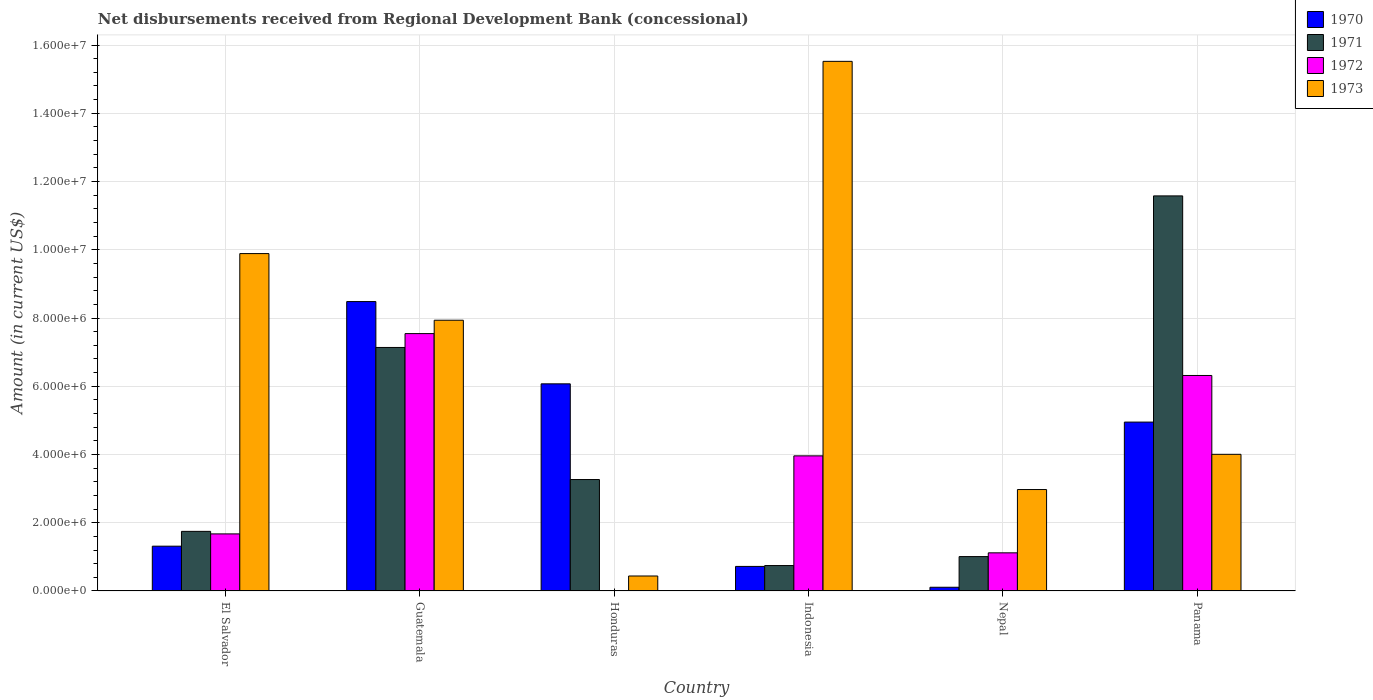How many different coloured bars are there?
Keep it short and to the point. 4. Are the number of bars on each tick of the X-axis equal?
Ensure brevity in your answer.  No. How many bars are there on the 3rd tick from the left?
Provide a short and direct response. 3. How many bars are there on the 1st tick from the right?
Offer a terse response. 4. What is the label of the 1st group of bars from the left?
Your answer should be very brief. El Salvador. What is the amount of disbursements received from Regional Development Bank in 1972 in Panama?
Provide a succinct answer. 6.32e+06. Across all countries, what is the maximum amount of disbursements received from Regional Development Bank in 1970?
Your response must be concise. 8.48e+06. Across all countries, what is the minimum amount of disbursements received from Regional Development Bank in 1970?
Provide a short and direct response. 1.09e+05. In which country was the amount of disbursements received from Regional Development Bank in 1972 maximum?
Provide a short and direct response. Guatemala. What is the total amount of disbursements received from Regional Development Bank in 1973 in the graph?
Provide a short and direct response. 4.08e+07. What is the difference between the amount of disbursements received from Regional Development Bank in 1970 in El Salvador and that in Nepal?
Ensure brevity in your answer.  1.20e+06. What is the difference between the amount of disbursements received from Regional Development Bank in 1973 in Nepal and the amount of disbursements received from Regional Development Bank in 1972 in Honduras?
Your response must be concise. 2.97e+06. What is the average amount of disbursements received from Regional Development Bank in 1972 per country?
Make the answer very short. 3.44e+06. What is the difference between the amount of disbursements received from Regional Development Bank of/in 1972 and amount of disbursements received from Regional Development Bank of/in 1973 in Panama?
Your response must be concise. 2.31e+06. What is the ratio of the amount of disbursements received from Regional Development Bank in 1970 in El Salvador to that in Nepal?
Ensure brevity in your answer.  12.05. What is the difference between the highest and the second highest amount of disbursements received from Regional Development Bank in 1971?
Ensure brevity in your answer.  4.44e+06. What is the difference between the highest and the lowest amount of disbursements received from Regional Development Bank in 1971?
Offer a terse response. 1.08e+07. In how many countries, is the amount of disbursements received from Regional Development Bank in 1971 greater than the average amount of disbursements received from Regional Development Bank in 1971 taken over all countries?
Provide a succinct answer. 2. Is the sum of the amount of disbursements received from Regional Development Bank in 1973 in Nepal and Panama greater than the maximum amount of disbursements received from Regional Development Bank in 1972 across all countries?
Ensure brevity in your answer.  No. Is it the case that in every country, the sum of the amount of disbursements received from Regional Development Bank in 1971 and amount of disbursements received from Regional Development Bank in 1970 is greater than the sum of amount of disbursements received from Regional Development Bank in 1972 and amount of disbursements received from Regional Development Bank in 1973?
Ensure brevity in your answer.  No. What is the difference between two consecutive major ticks on the Y-axis?
Your answer should be compact. 2.00e+06. Does the graph contain any zero values?
Your response must be concise. Yes. Does the graph contain grids?
Provide a short and direct response. Yes. How many legend labels are there?
Make the answer very short. 4. What is the title of the graph?
Provide a succinct answer. Net disbursements received from Regional Development Bank (concessional). Does "1988" appear as one of the legend labels in the graph?
Ensure brevity in your answer.  No. What is the label or title of the X-axis?
Keep it short and to the point. Country. What is the Amount (in current US$) of 1970 in El Salvador?
Offer a terse response. 1.31e+06. What is the Amount (in current US$) of 1971 in El Salvador?
Give a very brief answer. 1.75e+06. What is the Amount (in current US$) of 1972 in El Salvador?
Provide a succinct answer. 1.67e+06. What is the Amount (in current US$) in 1973 in El Salvador?
Give a very brief answer. 9.89e+06. What is the Amount (in current US$) in 1970 in Guatemala?
Ensure brevity in your answer.  8.48e+06. What is the Amount (in current US$) in 1971 in Guatemala?
Make the answer very short. 7.14e+06. What is the Amount (in current US$) in 1972 in Guatemala?
Ensure brevity in your answer.  7.54e+06. What is the Amount (in current US$) of 1973 in Guatemala?
Provide a succinct answer. 7.94e+06. What is the Amount (in current US$) of 1970 in Honduras?
Your response must be concise. 6.07e+06. What is the Amount (in current US$) in 1971 in Honduras?
Give a very brief answer. 3.27e+06. What is the Amount (in current US$) in 1973 in Honduras?
Your answer should be very brief. 4.39e+05. What is the Amount (in current US$) in 1970 in Indonesia?
Offer a terse response. 7.20e+05. What is the Amount (in current US$) of 1971 in Indonesia?
Your answer should be very brief. 7.45e+05. What is the Amount (in current US$) of 1972 in Indonesia?
Provide a short and direct response. 3.96e+06. What is the Amount (in current US$) of 1973 in Indonesia?
Your answer should be compact. 1.55e+07. What is the Amount (in current US$) of 1970 in Nepal?
Your answer should be compact. 1.09e+05. What is the Amount (in current US$) in 1971 in Nepal?
Provide a short and direct response. 1.01e+06. What is the Amount (in current US$) in 1972 in Nepal?
Ensure brevity in your answer.  1.12e+06. What is the Amount (in current US$) in 1973 in Nepal?
Make the answer very short. 2.97e+06. What is the Amount (in current US$) of 1970 in Panama?
Your answer should be very brief. 4.95e+06. What is the Amount (in current US$) in 1971 in Panama?
Give a very brief answer. 1.16e+07. What is the Amount (in current US$) in 1972 in Panama?
Provide a succinct answer. 6.32e+06. What is the Amount (in current US$) of 1973 in Panama?
Your answer should be very brief. 4.00e+06. Across all countries, what is the maximum Amount (in current US$) in 1970?
Offer a very short reply. 8.48e+06. Across all countries, what is the maximum Amount (in current US$) in 1971?
Offer a very short reply. 1.16e+07. Across all countries, what is the maximum Amount (in current US$) of 1972?
Provide a succinct answer. 7.54e+06. Across all countries, what is the maximum Amount (in current US$) in 1973?
Give a very brief answer. 1.55e+07. Across all countries, what is the minimum Amount (in current US$) in 1970?
Keep it short and to the point. 1.09e+05. Across all countries, what is the minimum Amount (in current US$) of 1971?
Your answer should be very brief. 7.45e+05. Across all countries, what is the minimum Amount (in current US$) in 1973?
Offer a terse response. 4.39e+05. What is the total Amount (in current US$) of 1970 in the graph?
Offer a very short reply. 2.16e+07. What is the total Amount (in current US$) of 1971 in the graph?
Provide a short and direct response. 2.55e+07. What is the total Amount (in current US$) of 1972 in the graph?
Make the answer very short. 2.06e+07. What is the total Amount (in current US$) in 1973 in the graph?
Give a very brief answer. 4.08e+07. What is the difference between the Amount (in current US$) in 1970 in El Salvador and that in Guatemala?
Offer a very short reply. -7.17e+06. What is the difference between the Amount (in current US$) in 1971 in El Salvador and that in Guatemala?
Your answer should be very brief. -5.39e+06. What is the difference between the Amount (in current US$) in 1972 in El Salvador and that in Guatemala?
Your answer should be very brief. -5.87e+06. What is the difference between the Amount (in current US$) of 1973 in El Salvador and that in Guatemala?
Your answer should be very brief. 1.95e+06. What is the difference between the Amount (in current US$) of 1970 in El Salvador and that in Honduras?
Your answer should be very brief. -4.76e+06. What is the difference between the Amount (in current US$) of 1971 in El Salvador and that in Honduras?
Offer a terse response. -1.52e+06. What is the difference between the Amount (in current US$) of 1973 in El Salvador and that in Honduras?
Provide a short and direct response. 9.45e+06. What is the difference between the Amount (in current US$) of 1970 in El Salvador and that in Indonesia?
Make the answer very short. 5.93e+05. What is the difference between the Amount (in current US$) in 1971 in El Salvador and that in Indonesia?
Ensure brevity in your answer.  1.00e+06. What is the difference between the Amount (in current US$) of 1972 in El Salvador and that in Indonesia?
Give a very brief answer. -2.29e+06. What is the difference between the Amount (in current US$) in 1973 in El Salvador and that in Indonesia?
Keep it short and to the point. -5.63e+06. What is the difference between the Amount (in current US$) in 1970 in El Salvador and that in Nepal?
Provide a short and direct response. 1.20e+06. What is the difference between the Amount (in current US$) of 1971 in El Salvador and that in Nepal?
Keep it short and to the point. 7.39e+05. What is the difference between the Amount (in current US$) of 1972 in El Salvador and that in Nepal?
Keep it short and to the point. 5.55e+05. What is the difference between the Amount (in current US$) of 1973 in El Salvador and that in Nepal?
Your answer should be compact. 6.92e+06. What is the difference between the Amount (in current US$) of 1970 in El Salvador and that in Panama?
Provide a short and direct response. -3.64e+06. What is the difference between the Amount (in current US$) of 1971 in El Salvador and that in Panama?
Offer a very short reply. -9.83e+06. What is the difference between the Amount (in current US$) in 1972 in El Salvador and that in Panama?
Your response must be concise. -4.64e+06. What is the difference between the Amount (in current US$) in 1973 in El Salvador and that in Panama?
Provide a succinct answer. 5.88e+06. What is the difference between the Amount (in current US$) in 1970 in Guatemala and that in Honduras?
Your response must be concise. 2.41e+06. What is the difference between the Amount (in current US$) in 1971 in Guatemala and that in Honduras?
Ensure brevity in your answer.  3.87e+06. What is the difference between the Amount (in current US$) in 1973 in Guatemala and that in Honduras?
Keep it short and to the point. 7.50e+06. What is the difference between the Amount (in current US$) of 1970 in Guatemala and that in Indonesia?
Your answer should be compact. 7.76e+06. What is the difference between the Amount (in current US$) in 1971 in Guatemala and that in Indonesia?
Make the answer very short. 6.39e+06. What is the difference between the Amount (in current US$) in 1972 in Guatemala and that in Indonesia?
Make the answer very short. 3.58e+06. What is the difference between the Amount (in current US$) in 1973 in Guatemala and that in Indonesia?
Offer a very short reply. -7.59e+06. What is the difference between the Amount (in current US$) of 1970 in Guatemala and that in Nepal?
Keep it short and to the point. 8.37e+06. What is the difference between the Amount (in current US$) in 1971 in Guatemala and that in Nepal?
Keep it short and to the point. 6.13e+06. What is the difference between the Amount (in current US$) of 1972 in Guatemala and that in Nepal?
Your answer should be compact. 6.42e+06. What is the difference between the Amount (in current US$) of 1973 in Guatemala and that in Nepal?
Offer a very short reply. 4.96e+06. What is the difference between the Amount (in current US$) in 1970 in Guatemala and that in Panama?
Give a very brief answer. 3.53e+06. What is the difference between the Amount (in current US$) in 1971 in Guatemala and that in Panama?
Provide a succinct answer. -4.44e+06. What is the difference between the Amount (in current US$) in 1972 in Guatemala and that in Panama?
Provide a short and direct response. 1.23e+06. What is the difference between the Amount (in current US$) in 1973 in Guatemala and that in Panama?
Keep it short and to the point. 3.93e+06. What is the difference between the Amount (in current US$) of 1970 in Honduras and that in Indonesia?
Offer a very short reply. 5.35e+06. What is the difference between the Amount (in current US$) in 1971 in Honduras and that in Indonesia?
Keep it short and to the point. 2.52e+06. What is the difference between the Amount (in current US$) of 1973 in Honduras and that in Indonesia?
Provide a succinct answer. -1.51e+07. What is the difference between the Amount (in current US$) of 1970 in Honduras and that in Nepal?
Offer a very short reply. 5.96e+06. What is the difference between the Amount (in current US$) in 1971 in Honduras and that in Nepal?
Ensure brevity in your answer.  2.26e+06. What is the difference between the Amount (in current US$) of 1973 in Honduras and that in Nepal?
Keep it short and to the point. -2.53e+06. What is the difference between the Amount (in current US$) of 1970 in Honduras and that in Panama?
Your answer should be compact. 1.12e+06. What is the difference between the Amount (in current US$) of 1971 in Honduras and that in Panama?
Offer a very short reply. -8.31e+06. What is the difference between the Amount (in current US$) in 1973 in Honduras and that in Panama?
Provide a succinct answer. -3.57e+06. What is the difference between the Amount (in current US$) in 1970 in Indonesia and that in Nepal?
Your answer should be compact. 6.11e+05. What is the difference between the Amount (in current US$) of 1971 in Indonesia and that in Nepal?
Offer a terse response. -2.63e+05. What is the difference between the Amount (in current US$) of 1972 in Indonesia and that in Nepal?
Ensure brevity in your answer.  2.84e+06. What is the difference between the Amount (in current US$) of 1973 in Indonesia and that in Nepal?
Provide a succinct answer. 1.25e+07. What is the difference between the Amount (in current US$) of 1970 in Indonesia and that in Panama?
Your answer should be very brief. -4.23e+06. What is the difference between the Amount (in current US$) of 1971 in Indonesia and that in Panama?
Your response must be concise. -1.08e+07. What is the difference between the Amount (in current US$) in 1972 in Indonesia and that in Panama?
Give a very brief answer. -2.36e+06. What is the difference between the Amount (in current US$) in 1973 in Indonesia and that in Panama?
Provide a succinct answer. 1.15e+07. What is the difference between the Amount (in current US$) in 1970 in Nepal and that in Panama?
Give a very brief answer. -4.84e+06. What is the difference between the Amount (in current US$) of 1971 in Nepal and that in Panama?
Offer a terse response. -1.06e+07. What is the difference between the Amount (in current US$) in 1972 in Nepal and that in Panama?
Provide a succinct answer. -5.20e+06. What is the difference between the Amount (in current US$) in 1973 in Nepal and that in Panama?
Your answer should be very brief. -1.03e+06. What is the difference between the Amount (in current US$) of 1970 in El Salvador and the Amount (in current US$) of 1971 in Guatemala?
Your answer should be compact. -5.82e+06. What is the difference between the Amount (in current US$) of 1970 in El Salvador and the Amount (in current US$) of 1972 in Guatemala?
Give a very brief answer. -6.23e+06. What is the difference between the Amount (in current US$) of 1970 in El Salvador and the Amount (in current US$) of 1973 in Guatemala?
Ensure brevity in your answer.  -6.62e+06. What is the difference between the Amount (in current US$) in 1971 in El Salvador and the Amount (in current US$) in 1972 in Guatemala?
Your answer should be compact. -5.80e+06. What is the difference between the Amount (in current US$) of 1971 in El Salvador and the Amount (in current US$) of 1973 in Guatemala?
Your answer should be compact. -6.19e+06. What is the difference between the Amount (in current US$) of 1972 in El Salvador and the Amount (in current US$) of 1973 in Guatemala?
Your answer should be compact. -6.26e+06. What is the difference between the Amount (in current US$) in 1970 in El Salvador and the Amount (in current US$) in 1971 in Honduras?
Your answer should be compact. -1.95e+06. What is the difference between the Amount (in current US$) in 1970 in El Salvador and the Amount (in current US$) in 1973 in Honduras?
Give a very brief answer. 8.74e+05. What is the difference between the Amount (in current US$) of 1971 in El Salvador and the Amount (in current US$) of 1973 in Honduras?
Offer a very short reply. 1.31e+06. What is the difference between the Amount (in current US$) in 1972 in El Salvador and the Amount (in current US$) in 1973 in Honduras?
Keep it short and to the point. 1.23e+06. What is the difference between the Amount (in current US$) of 1970 in El Salvador and the Amount (in current US$) of 1971 in Indonesia?
Your answer should be compact. 5.68e+05. What is the difference between the Amount (in current US$) in 1970 in El Salvador and the Amount (in current US$) in 1972 in Indonesia?
Offer a very short reply. -2.65e+06. What is the difference between the Amount (in current US$) in 1970 in El Salvador and the Amount (in current US$) in 1973 in Indonesia?
Provide a succinct answer. -1.42e+07. What is the difference between the Amount (in current US$) in 1971 in El Salvador and the Amount (in current US$) in 1972 in Indonesia?
Give a very brief answer. -2.21e+06. What is the difference between the Amount (in current US$) in 1971 in El Salvador and the Amount (in current US$) in 1973 in Indonesia?
Give a very brief answer. -1.38e+07. What is the difference between the Amount (in current US$) in 1972 in El Salvador and the Amount (in current US$) in 1973 in Indonesia?
Your response must be concise. -1.38e+07. What is the difference between the Amount (in current US$) in 1970 in El Salvador and the Amount (in current US$) in 1971 in Nepal?
Give a very brief answer. 3.05e+05. What is the difference between the Amount (in current US$) of 1970 in El Salvador and the Amount (in current US$) of 1972 in Nepal?
Your answer should be very brief. 1.95e+05. What is the difference between the Amount (in current US$) of 1970 in El Salvador and the Amount (in current US$) of 1973 in Nepal?
Provide a succinct answer. -1.66e+06. What is the difference between the Amount (in current US$) in 1971 in El Salvador and the Amount (in current US$) in 1972 in Nepal?
Your response must be concise. 6.29e+05. What is the difference between the Amount (in current US$) of 1971 in El Salvador and the Amount (in current US$) of 1973 in Nepal?
Give a very brief answer. -1.23e+06. What is the difference between the Amount (in current US$) of 1972 in El Salvador and the Amount (in current US$) of 1973 in Nepal?
Provide a succinct answer. -1.30e+06. What is the difference between the Amount (in current US$) of 1970 in El Salvador and the Amount (in current US$) of 1971 in Panama?
Offer a terse response. -1.03e+07. What is the difference between the Amount (in current US$) in 1970 in El Salvador and the Amount (in current US$) in 1972 in Panama?
Provide a short and direct response. -5.00e+06. What is the difference between the Amount (in current US$) in 1970 in El Salvador and the Amount (in current US$) in 1973 in Panama?
Offer a terse response. -2.69e+06. What is the difference between the Amount (in current US$) of 1971 in El Salvador and the Amount (in current US$) of 1972 in Panama?
Offer a very short reply. -4.57e+06. What is the difference between the Amount (in current US$) in 1971 in El Salvador and the Amount (in current US$) in 1973 in Panama?
Provide a succinct answer. -2.26e+06. What is the difference between the Amount (in current US$) of 1972 in El Salvador and the Amount (in current US$) of 1973 in Panama?
Give a very brief answer. -2.33e+06. What is the difference between the Amount (in current US$) of 1970 in Guatemala and the Amount (in current US$) of 1971 in Honduras?
Offer a terse response. 5.22e+06. What is the difference between the Amount (in current US$) in 1970 in Guatemala and the Amount (in current US$) in 1973 in Honduras?
Your answer should be very brief. 8.04e+06. What is the difference between the Amount (in current US$) of 1971 in Guatemala and the Amount (in current US$) of 1973 in Honduras?
Ensure brevity in your answer.  6.70e+06. What is the difference between the Amount (in current US$) of 1972 in Guatemala and the Amount (in current US$) of 1973 in Honduras?
Ensure brevity in your answer.  7.10e+06. What is the difference between the Amount (in current US$) of 1970 in Guatemala and the Amount (in current US$) of 1971 in Indonesia?
Your answer should be compact. 7.74e+06. What is the difference between the Amount (in current US$) in 1970 in Guatemala and the Amount (in current US$) in 1972 in Indonesia?
Your answer should be very brief. 4.52e+06. What is the difference between the Amount (in current US$) of 1970 in Guatemala and the Amount (in current US$) of 1973 in Indonesia?
Provide a succinct answer. -7.04e+06. What is the difference between the Amount (in current US$) of 1971 in Guatemala and the Amount (in current US$) of 1972 in Indonesia?
Make the answer very short. 3.18e+06. What is the difference between the Amount (in current US$) of 1971 in Guatemala and the Amount (in current US$) of 1973 in Indonesia?
Ensure brevity in your answer.  -8.38e+06. What is the difference between the Amount (in current US$) in 1972 in Guatemala and the Amount (in current US$) in 1973 in Indonesia?
Make the answer very short. -7.98e+06. What is the difference between the Amount (in current US$) of 1970 in Guatemala and the Amount (in current US$) of 1971 in Nepal?
Provide a short and direct response. 7.47e+06. What is the difference between the Amount (in current US$) in 1970 in Guatemala and the Amount (in current US$) in 1972 in Nepal?
Make the answer very short. 7.36e+06. What is the difference between the Amount (in current US$) in 1970 in Guatemala and the Amount (in current US$) in 1973 in Nepal?
Your answer should be compact. 5.51e+06. What is the difference between the Amount (in current US$) in 1971 in Guatemala and the Amount (in current US$) in 1972 in Nepal?
Give a very brief answer. 6.02e+06. What is the difference between the Amount (in current US$) in 1971 in Guatemala and the Amount (in current US$) in 1973 in Nepal?
Provide a short and direct response. 4.16e+06. What is the difference between the Amount (in current US$) of 1972 in Guatemala and the Amount (in current US$) of 1973 in Nepal?
Your answer should be compact. 4.57e+06. What is the difference between the Amount (in current US$) of 1970 in Guatemala and the Amount (in current US$) of 1971 in Panama?
Your answer should be very brief. -3.10e+06. What is the difference between the Amount (in current US$) in 1970 in Guatemala and the Amount (in current US$) in 1972 in Panama?
Your answer should be very brief. 2.17e+06. What is the difference between the Amount (in current US$) of 1970 in Guatemala and the Amount (in current US$) of 1973 in Panama?
Give a very brief answer. 4.48e+06. What is the difference between the Amount (in current US$) in 1971 in Guatemala and the Amount (in current US$) in 1972 in Panama?
Provide a short and direct response. 8.21e+05. What is the difference between the Amount (in current US$) in 1971 in Guatemala and the Amount (in current US$) in 1973 in Panama?
Ensure brevity in your answer.  3.13e+06. What is the difference between the Amount (in current US$) of 1972 in Guatemala and the Amount (in current US$) of 1973 in Panama?
Provide a short and direct response. 3.54e+06. What is the difference between the Amount (in current US$) in 1970 in Honduras and the Amount (in current US$) in 1971 in Indonesia?
Ensure brevity in your answer.  5.33e+06. What is the difference between the Amount (in current US$) in 1970 in Honduras and the Amount (in current US$) in 1972 in Indonesia?
Ensure brevity in your answer.  2.11e+06. What is the difference between the Amount (in current US$) of 1970 in Honduras and the Amount (in current US$) of 1973 in Indonesia?
Keep it short and to the point. -9.45e+06. What is the difference between the Amount (in current US$) in 1971 in Honduras and the Amount (in current US$) in 1972 in Indonesia?
Your answer should be very brief. -6.94e+05. What is the difference between the Amount (in current US$) in 1971 in Honduras and the Amount (in current US$) in 1973 in Indonesia?
Provide a succinct answer. -1.23e+07. What is the difference between the Amount (in current US$) in 1970 in Honduras and the Amount (in current US$) in 1971 in Nepal?
Your answer should be compact. 5.06e+06. What is the difference between the Amount (in current US$) in 1970 in Honduras and the Amount (in current US$) in 1972 in Nepal?
Provide a short and direct response. 4.95e+06. What is the difference between the Amount (in current US$) of 1970 in Honduras and the Amount (in current US$) of 1973 in Nepal?
Offer a very short reply. 3.10e+06. What is the difference between the Amount (in current US$) in 1971 in Honduras and the Amount (in current US$) in 1972 in Nepal?
Give a very brief answer. 2.15e+06. What is the difference between the Amount (in current US$) of 1971 in Honduras and the Amount (in current US$) of 1973 in Nepal?
Keep it short and to the point. 2.93e+05. What is the difference between the Amount (in current US$) of 1970 in Honduras and the Amount (in current US$) of 1971 in Panama?
Provide a short and direct response. -5.51e+06. What is the difference between the Amount (in current US$) of 1970 in Honduras and the Amount (in current US$) of 1972 in Panama?
Your answer should be compact. -2.45e+05. What is the difference between the Amount (in current US$) of 1970 in Honduras and the Amount (in current US$) of 1973 in Panama?
Your answer should be very brief. 2.07e+06. What is the difference between the Amount (in current US$) in 1971 in Honduras and the Amount (in current US$) in 1972 in Panama?
Offer a terse response. -3.05e+06. What is the difference between the Amount (in current US$) of 1971 in Honduras and the Amount (in current US$) of 1973 in Panama?
Give a very brief answer. -7.39e+05. What is the difference between the Amount (in current US$) of 1970 in Indonesia and the Amount (in current US$) of 1971 in Nepal?
Your answer should be very brief. -2.88e+05. What is the difference between the Amount (in current US$) of 1970 in Indonesia and the Amount (in current US$) of 1972 in Nepal?
Offer a terse response. -3.98e+05. What is the difference between the Amount (in current US$) in 1970 in Indonesia and the Amount (in current US$) in 1973 in Nepal?
Your answer should be compact. -2.25e+06. What is the difference between the Amount (in current US$) in 1971 in Indonesia and the Amount (in current US$) in 1972 in Nepal?
Provide a succinct answer. -3.73e+05. What is the difference between the Amount (in current US$) of 1971 in Indonesia and the Amount (in current US$) of 1973 in Nepal?
Keep it short and to the point. -2.23e+06. What is the difference between the Amount (in current US$) of 1972 in Indonesia and the Amount (in current US$) of 1973 in Nepal?
Offer a very short reply. 9.87e+05. What is the difference between the Amount (in current US$) of 1970 in Indonesia and the Amount (in current US$) of 1971 in Panama?
Your answer should be compact. -1.09e+07. What is the difference between the Amount (in current US$) of 1970 in Indonesia and the Amount (in current US$) of 1972 in Panama?
Provide a succinct answer. -5.60e+06. What is the difference between the Amount (in current US$) of 1970 in Indonesia and the Amount (in current US$) of 1973 in Panama?
Ensure brevity in your answer.  -3.28e+06. What is the difference between the Amount (in current US$) of 1971 in Indonesia and the Amount (in current US$) of 1972 in Panama?
Your response must be concise. -5.57e+06. What is the difference between the Amount (in current US$) in 1971 in Indonesia and the Amount (in current US$) in 1973 in Panama?
Ensure brevity in your answer.  -3.26e+06. What is the difference between the Amount (in current US$) of 1972 in Indonesia and the Amount (in current US$) of 1973 in Panama?
Ensure brevity in your answer.  -4.50e+04. What is the difference between the Amount (in current US$) in 1970 in Nepal and the Amount (in current US$) in 1971 in Panama?
Provide a short and direct response. -1.15e+07. What is the difference between the Amount (in current US$) of 1970 in Nepal and the Amount (in current US$) of 1972 in Panama?
Your answer should be very brief. -6.21e+06. What is the difference between the Amount (in current US$) in 1970 in Nepal and the Amount (in current US$) in 1973 in Panama?
Offer a terse response. -3.90e+06. What is the difference between the Amount (in current US$) of 1971 in Nepal and the Amount (in current US$) of 1972 in Panama?
Your answer should be very brief. -5.31e+06. What is the difference between the Amount (in current US$) of 1971 in Nepal and the Amount (in current US$) of 1973 in Panama?
Provide a succinct answer. -3.00e+06. What is the difference between the Amount (in current US$) in 1972 in Nepal and the Amount (in current US$) in 1973 in Panama?
Offer a terse response. -2.89e+06. What is the average Amount (in current US$) of 1970 per country?
Your answer should be very brief. 3.61e+06. What is the average Amount (in current US$) of 1971 per country?
Ensure brevity in your answer.  4.25e+06. What is the average Amount (in current US$) in 1972 per country?
Provide a short and direct response. 3.44e+06. What is the average Amount (in current US$) of 1973 per country?
Offer a very short reply. 6.79e+06. What is the difference between the Amount (in current US$) in 1970 and Amount (in current US$) in 1971 in El Salvador?
Offer a terse response. -4.34e+05. What is the difference between the Amount (in current US$) of 1970 and Amount (in current US$) of 1972 in El Salvador?
Keep it short and to the point. -3.60e+05. What is the difference between the Amount (in current US$) in 1970 and Amount (in current US$) in 1973 in El Salvador?
Your answer should be compact. -8.58e+06. What is the difference between the Amount (in current US$) of 1971 and Amount (in current US$) of 1972 in El Salvador?
Provide a succinct answer. 7.40e+04. What is the difference between the Amount (in current US$) in 1971 and Amount (in current US$) in 1973 in El Salvador?
Give a very brief answer. -8.14e+06. What is the difference between the Amount (in current US$) in 1972 and Amount (in current US$) in 1973 in El Salvador?
Your answer should be compact. -8.22e+06. What is the difference between the Amount (in current US$) in 1970 and Amount (in current US$) in 1971 in Guatemala?
Provide a succinct answer. 1.34e+06. What is the difference between the Amount (in current US$) in 1970 and Amount (in current US$) in 1972 in Guatemala?
Your answer should be very brief. 9.39e+05. What is the difference between the Amount (in current US$) of 1970 and Amount (in current US$) of 1973 in Guatemala?
Your answer should be compact. 5.47e+05. What is the difference between the Amount (in current US$) in 1971 and Amount (in current US$) in 1972 in Guatemala?
Ensure brevity in your answer.  -4.06e+05. What is the difference between the Amount (in current US$) in 1971 and Amount (in current US$) in 1973 in Guatemala?
Provide a succinct answer. -7.98e+05. What is the difference between the Amount (in current US$) in 1972 and Amount (in current US$) in 1973 in Guatemala?
Give a very brief answer. -3.92e+05. What is the difference between the Amount (in current US$) in 1970 and Amount (in current US$) in 1971 in Honduras?
Ensure brevity in your answer.  2.80e+06. What is the difference between the Amount (in current US$) in 1970 and Amount (in current US$) in 1973 in Honduras?
Offer a very short reply. 5.63e+06. What is the difference between the Amount (in current US$) in 1971 and Amount (in current US$) in 1973 in Honduras?
Your response must be concise. 2.83e+06. What is the difference between the Amount (in current US$) of 1970 and Amount (in current US$) of 1971 in Indonesia?
Make the answer very short. -2.50e+04. What is the difference between the Amount (in current US$) of 1970 and Amount (in current US$) of 1972 in Indonesia?
Ensure brevity in your answer.  -3.24e+06. What is the difference between the Amount (in current US$) of 1970 and Amount (in current US$) of 1973 in Indonesia?
Your answer should be very brief. -1.48e+07. What is the difference between the Amount (in current US$) in 1971 and Amount (in current US$) in 1972 in Indonesia?
Give a very brief answer. -3.22e+06. What is the difference between the Amount (in current US$) in 1971 and Amount (in current US$) in 1973 in Indonesia?
Keep it short and to the point. -1.48e+07. What is the difference between the Amount (in current US$) in 1972 and Amount (in current US$) in 1973 in Indonesia?
Your answer should be very brief. -1.16e+07. What is the difference between the Amount (in current US$) in 1970 and Amount (in current US$) in 1971 in Nepal?
Keep it short and to the point. -8.99e+05. What is the difference between the Amount (in current US$) of 1970 and Amount (in current US$) of 1972 in Nepal?
Ensure brevity in your answer.  -1.01e+06. What is the difference between the Amount (in current US$) in 1970 and Amount (in current US$) in 1973 in Nepal?
Offer a terse response. -2.86e+06. What is the difference between the Amount (in current US$) of 1971 and Amount (in current US$) of 1973 in Nepal?
Provide a succinct answer. -1.96e+06. What is the difference between the Amount (in current US$) of 1972 and Amount (in current US$) of 1973 in Nepal?
Give a very brief answer. -1.86e+06. What is the difference between the Amount (in current US$) in 1970 and Amount (in current US$) in 1971 in Panama?
Your answer should be compact. -6.63e+06. What is the difference between the Amount (in current US$) of 1970 and Amount (in current US$) of 1972 in Panama?
Your answer should be compact. -1.37e+06. What is the difference between the Amount (in current US$) of 1970 and Amount (in current US$) of 1973 in Panama?
Offer a terse response. 9.45e+05. What is the difference between the Amount (in current US$) of 1971 and Amount (in current US$) of 1972 in Panama?
Offer a very short reply. 5.26e+06. What is the difference between the Amount (in current US$) in 1971 and Amount (in current US$) in 1973 in Panama?
Give a very brief answer. 7.57e+06. What is the difference between the Amount (in current US$) of 1972 and Amount (in current US$) of 1973 in Panama?
Your response must be concise. 2.31e+06. What is the ratio of the Amount (in current US$) of 1970 in El Salvador to that in Guatemala?
Your answer should be very brief. 0.15. What is the ratio of the Amount (in current US$) of 1971 in El Salvador to that in Guatemala?
Give a very brief answer. 0.24. What is the ratio of the Amount (in current US$) in 1972 in El Salvador to that in Guatemala?
Keep it short and to the point. 0.22. What is the ratio of the Amount (in current US$) of 1973 in El Salvador to that in Guatemala?
Offer a very short reply. 1.25. What is the ratio of the Amount (in current US$) of 1970 in El Salvador to that in Honduras?
Ensure brevity in your answer.  0.22. What is the ratio of the Amount (in current US$) of 1971 in El Salvador to that in Honduras?
Provide a short and direct response. 0.53. What is the ratio of the Amount (in current US$) in 1973 in El Salvador to that in Honduras?
Offer a very short reply. 22.52. What is the ratio of the Amount (in current US$) of 1970 in El Salvador to that in Indonesia?
Ensure brevity in your answer.  1.82. What is the ratio of the Amount (in current US$) in 1971 in El Salvador to that in Indonesia?
Provide a short and direct response. 2.35. What is the ratio of the Amount (in current US$) of 1972 in El Salvador to that in Indonesia?
Offer a terse response. 0.42. What is the ratio of the Amount (in current US$) of 1973 in El Salvador to that in Indonesia?
Your answer should be compact. 0.64. What is the ratio of the Amount (in current US$) in 1970 in El Salvador to that in Nepal?
Give a very brief answer. 12.05. What is the ratio of the Amount (in current US$) in 1971 in El Salvador to that in Nepal?
Provide a succinct answer. 1.73. What is the ratio of the Amount (in current US$) of 1972 in El Salvador to that in Nepal?
Give a very brief answer. 1.5. What is the ratio of the Amount (in current US$) in 1973 in El Salvador to that in Nepal?
Make the answer very short. 3.33. What is the ratio of the Amount (in current US$) in 1970 in El Salvador to that in Panama?
Offer a terse response. 0.27. What is the ratio of the Amount (in current US$) in 1971 in El Salvador to that in Panama?
Offer a very short reply. 0.15. What is the ratio of the Amount (in current US$) of 1972 in El Salvador to that in Panama?
Offer a very short reply. 0.26. What is the ratio of the Amount (in current US$) in 1973 in El Salvador to that in Panama?
Your answer should be very brief. 2.47. What is the ratio of the Amount (in current US$) in 1970 in Guatemala to that in Honduras?
Make the answer very short. 1.4. What is the ratio of the Amount (in current US$) of 1971 in Guatemala to that in Honduras?
Offer a very short reply. 2.19. What is the ratio of the Amount (in current US$) of 1973 in Guatemala to that in Honduras?
Your answer should be compact. 18.08. What is the ratio of the Amount (in current US$) of 1970 in Guatemala to that in Indonesia?
Your answer should be very brief. 11.78. What is the ratio of the Amount (in current US$) of 1971 in Guatemala to that in Indonesia?
Provide a succinct answer. 9.58. What is the ratio of the Amount (in current US$) in 1972 in Guatemala to that in Indonesia?
Your answer should be compact. 1.9. What is the ratio of the Amount (in current US$) of 1973 in Guatemala to that in Indonesia?
Your answer should be very brief. 0.51. What is the ratio of the Amount (in current US$) of 1970 in Guatemala to that in Nepal?
Provide a succinct answer. 77.82. What is the ratio of the Amount (in current US$) in 1971 in Guatemala to that in Nepal?
Give a very brief answer. 7.08. What is the ratio of the Amount (in current US$) of 1972 in Guatemala to that in Nepal?
Your answer should be very brief. 6.75. What is the ratio of the Amount (in current US$) of 1973 in Guatemala to that in Nepal?
Offer a terse response. 2.67. What is the ratio of the Amount (in current US$) in 1970 in Guatemala to that in Panama?
Offer a terse response. 1.71. What is the ratio of the Amount (in current US$) of 1971 in Guatemala to that in Panama?
Offer a very short reply. 0.62. What is the ratio of the Amount (in current US$) in 1972 in Guatemala to that in Panama?
Your response must be concise. 1.19. What is the ratio of the Amount (in current US$) of 1973 in Guatemala to that in Panama?
Make the answer very short. 1.98. What is the ratio of the Amount (in current US$) of 1970 in Honduras to that in Indonesia?
Offer a terse response. 8.43. What is the ratio of the Amount (in current US$) in 1971 in Honduras to that in Indonesia?
Your answer should be compact. 4.38. What is the ratio of the Amount (in current US$) of 1973 in Honduras to that in Indonesia?
Offer a very short reply. 0.03. What is the ratio of the Amount (in current US$) in 1970 in Honduras to that in Nepal?
Make the answer very short. 55.7. What is the ratio of the Amount (in current US$) in 1971 in Honduras to that in Nepal?
Provide a succinct answer. 3.24. What is the ratio of the Amount (in current US$) of 1973 in Honduras to that in Nepal?
Provide a short and direct response. 0.15. What is the ratio of the Amount (in current US$) in 1970 in Honduras to that in Panama?
Keep it short and to the point. 1.23. What is the ratio of the Amount (in current US$) of 1971 in Honduras to that in Panama?
Offer a very short reply. 0.28. What is the ratio of the Amount (in current US$) in 1973 in Honduras to that in Panama?
Your answer should be very brief. 0.11. What is the ratio of the Amount (in current US$) of 1970 in Indonesia to that in Nepal?
Provide a short and direct response. 6.61. What is the ratio of the Amount (in current US$) in 1971 in Indonesia to that in Nepal?
Ensure brevity in your answer.  0.74. What is the ratio of the Amount (in current US$) in 1972 in Indonesia to that in Nepal?
Your response must be concise. 3.54. What is the ratio of the Amount (in current US$) of 1973 in Indonesia to that in Nepal?
Provide a succinct answer. 5.22. What is the ratio of the Amount (in current US$) in 1970 in Indonesia to that in Panama?
Keep it short and to the point. 0.15. What is the ratio of the Amount (in current US$) of 1971 in Indonesia to that in Panama?
Your answer should be compact. 0.06. What is the ratio of the Amount (in current US$) of 1972 in Indonesia to that in Panama?
Offer a terse response. 0.63. What is the ratio of the Amount (in current US$) in 1973 in Indonesia to that in Panama?
Offer a very short reply. 3.88. What is the ratio of the Amount (in current US$) in 1970 in Nepal to that in Panama?
Keep it short and to the point. 0.02. What is the ratio of the Amount (in current US$) in 1971 in Nepal to that in Panama?
Offer a terse response. 0.09. What is the ratio of the Amount (in current US$) of 1972 in Nepal to that in Panama?
Your answer should be very brief. 0.18. What is the ratio of the Amount (in current US$) in 1973 in Nepal to that in Panama?
Provide a short and direct response. 0.74. What is the difference between the highest and the second highest Amount (in current US$) in 1970?
Your response must be concise. 2.41e+06. What is the difference between the highest and the second highest Amount (in current US$) in 1971?
Your answer should be compact. 4.44e+06. What is the difference between the highest and the second highest Amount (in current US$) in 1972?
Your response must be concise. 1.23e+06. What is the difference between the highest and the second highest Amount (in current US$) of 1973?
Offer a very short reply. 5.63e+06. What is the difference between the highest and the lowest Amount (in current US$) of 1970?
Provide a short and direct response. 8.37e+06. What is the difference between the highest and the lowest Amount (in current US$) of 1971?
Make the answer very short. 1.08e+07. What is the difference between the highest and the lowest Amount (in current US$) of 1972?
Provide a succinct answer. 7.54e+06. What is the difference between the highest and the lowest Amount (in current US$) in 1973?
Provide a short and direct response. 1.51e+07. 